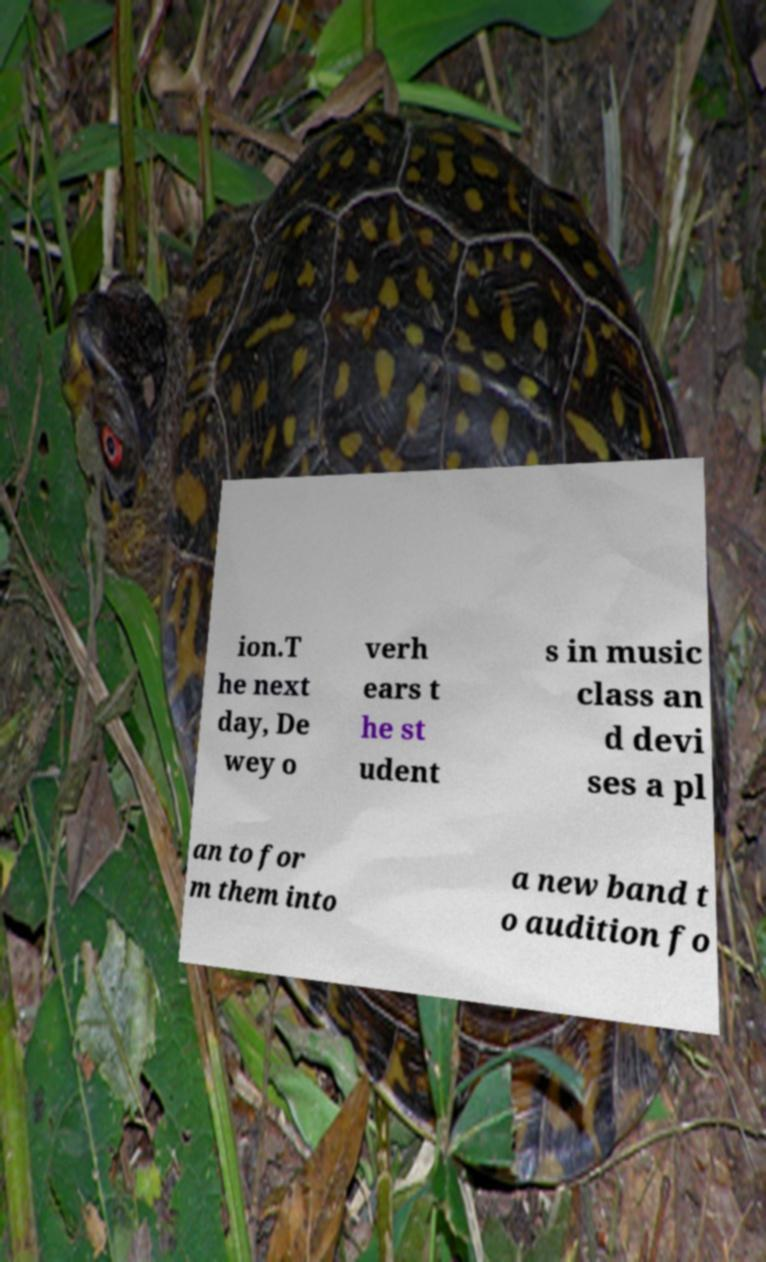Could you assist in decoding the text presented in this image and type it out clearly? ion.T he next day, De wey o verh ears t he st udent s in music class an d devi ses a pl an to for m them into a new band t o audition fo 